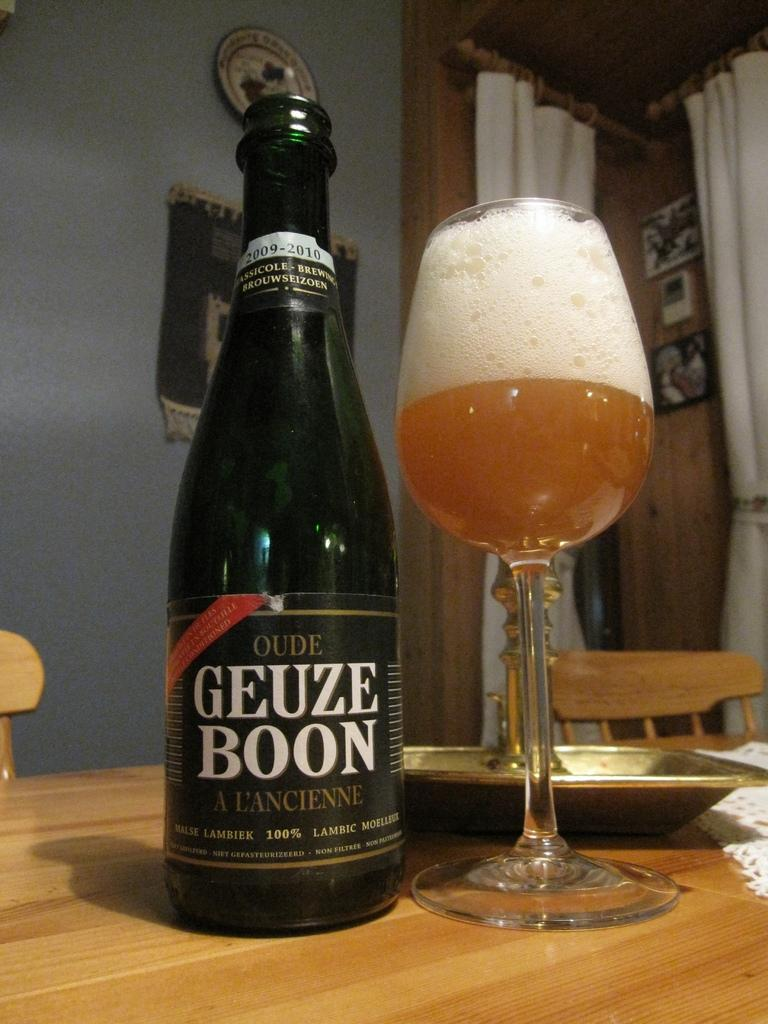<image>
Describe the image concisely. A bottle of Oude Geuze Boon A L'Ancienne is next to a glass into which it has been poured. 